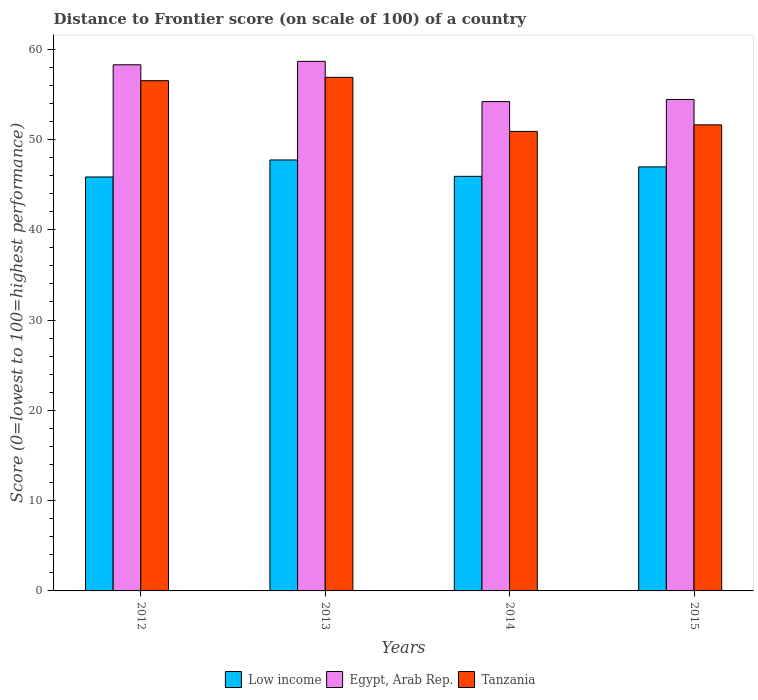How many groups of bars are there?
Provide a succinct answer. 4. Are the number of bars per tick equal to the number of legend labels?
Offer a terse response. Yes. Are the number of bars on each tick of the X-axis equal?
Keep it short and to the point. Yes. How many bars are there on the 2nd tick from the left?
Keep it short and to the point. 3. In how many cases, is the number of bars for a given year not equal to the number of legend labels?
Give a very brief answer. 0. What is the distance to frontier score of in Tanzania in 2014?
Give a very brief answer. 50.89. Across all years, what is the maximum distance to frontier score of in Low income?
Make the answer very short. 47.73. Across all years, what is the minimum distance to frontier score of in Egypt, Arab Rep.?
Provide a succinct answer. 54.19. In which year was the distance to frontier score of in Low income minimum?
Provide a short and direct response. 2012. What is the total distance to frontier score of in Low income in the graph?
Keep it short and to the point. 186.45. What is the difference between the distance to frontier score of in Low income in 2013 and that in 2015?
Your answer should be compact. 0.77. What is the difference between the distance to frontier score of in Low income in 2014 and the distance to frontier score of in Egypt, Arab Rep. in 2013?
Make the answer very short. -12.73. What is the average distance to frontier score of in Egypt, Arab Rep. per year?
Offer a terse response. 56.39. In the year 2015, what is the difference between the distance to frontier score of in Tanzania and distance to frontier score of in Low income?
Offer a very short reply. 4.66. What is the ratio of the distance to frontier score of in Low income in 2013 to that in 2014?
Give a very brief answer. 1.04. Is the distance to frontier score of in Tanzania in 2012 less than that in 2014?
Your answer should be compact. No. What is the difference between the highest and the second highest distance to frontier score of in Tanzania?
Your answer should be compact. 0.37. What is the difference between the highest and the lowest distance to frontier score of in Egypt, Arab Rep.?
Provide a short and direct response. 4.46. What does the 2nd bar from the left in 2012 represents?
Offer a very short reply. Egypt, Arab Rep. What does the 2nd bar from the right in 2012 represents?
Your answer should be compact. Egypt, Arab Rep. Is it the case that in every year, the sum of the distance to frontier score of in Tanzania and distance to frontier score of in Low income is greater than the distance to frontier score of in Egypt, Arab Rep.?
Ensure brevity in your answer.  Yes. How many bars are there?
Give a very brief answer. 12. Are all the bars in the graph horizontal?
Ensure brevity in your answer.  No. Does the graph contain grids?
Your answer should be compact. No. What is the title of the graph?
Offer a very short reply. Distance to Frontier score (on scale of 100) of a country. Does "Ghana" appear as one of the legend labels in the graph?
Your answer should be very brief. No. What is the label or title of the X-axis?
Make the answer very short. Years. What is the label or title of the Y-axis?
Your answer should be compact. Score (0=lowest to 100=highest performance). What is the Score (0=lowest to 100=highest performance) in Low income in 2012?
Provide a succinct answer. 45.84. What is the Score (0=lowest to 100=highest performance) of Egypt, Arab Rep. in 2012?
Offer a very short reply. 58.27. What is the Score (0=lowest to 100=highest performance) of Tanzania in 2012?
Your response must be concise. 56.51. What is the Score (0=lowest to 100=highest performance) in Low income in 2013?
Make the answer very short. 47.73. What is the Score (0=lowest to 100=highest performance) of Egypt, Arab Rep. in 2013?
Provide a short and direct response. 58.65. What is the Score (0=lowest to 100=highest performance) of Tanzania in 2013?
Keep it short and to the point. 56.88. What is the Score (0=lowest to 100=highest performance) in Low income in 2014?
Ensure brevity in your answer.  45.92. What is the Score (0=lowest to 100=highest performance) in Egypt, Arab Rep. in 2014?
Provide a succinct answer. 54.19. What is the Score (0=lowest to 100=highest performance) in Tanzania in 2014?
Your answer should be compact. 50.89. What is the Score (0=lowest to 100=highest performance) in Low income in 2015?
Your answer should be very brief. 46.96. What is the Score (0=lowest to 100=highest performance) of Egypt, Arab Rep. in 2015?
Offer a terse response. 54.43. What is the Score (0=lowest to 100=highest performance) of Tanzania in 2015?
Make the answer very short. 51.62. Across all years, what is the maximum Score (0=lowest to 100=highest performance) in Low income?
Your answer should be compact. 47.73. Across all years, what is the maximum Score (0=lowest to 100=highest performance) in Egypt, Arab Rep.?
Offer a terse response. 58.65. Across all years, what is the maximum Score (0=lowest to 100=highest performance) of Tanzania?
Ensure brevity in your answer.  56.88. Across all years, what is the minimum Score (0=lowest to 100=highest performance) of Low income?
Provide a short and direct response. 45.84. Across all years, what is the minimum Score (0=lowest to 100=highest performance) of Egypt, Arab Rep.?
Offer a very short reply. 54.19. Across all years, what is the minimum Score (0=lowest to 100=highest performance) of Tanzania?
Provide a short and direct response. 50.89. What is the total Score (0=lowest to 100=highest performance) of Low income in the graph?
Your answer should be very brief. 186.45. What is the total Score (0=lowest to 100=highest performance) in Egypt, Arab Rep. in the graph?
Your response must be concise. 225.54. What is the total Score (0=lowest to 100=highest performance) in Tanzania in the graph?
Offer a very short reply. 215.9. What is the difference between the Score (0=lowest to 100=highest performance) in Low income in 2012 and that in 2013?
Your answer should be compact. -1.89. What is the difference between the Score (0=lowest to 100=highest performance) in Egypt, Arab Rep. in 2012 and that in 2013?
Your response must be concise. -0.38. What is the difference between the Score (0=lowest to 100=highest performance) in Tanzania in 2012 and that in 2013?
Your answer should be very brief. -0.37. What is the difference between the Score (0=lowest to 100=highest performance) of Low income in 2012 and that in 2014?
Make the answer very short. -0.07. What is the difference between the Score (0=lowest to 100=highest performance) in Egypt, Arab Rep. in 2012 and that in 2014?
Your answer should be compact. 4.08. What is the difference between the Score (0=lowest to 100=highest performance) of Tanzania in 2012 and that in 2014?
Provide a short and direct response. 5.62. What is the difference between the Score (0=lowest to 100=highest performance) in Low income in 2012 and that in 2015?
Give a very brief answer. -1.12. What is the difference between the Score (0=lowest to 100=highest performance) in Egypt, Arab Rep. in 2012 and that in 2015?
Offer a very short reply. 3.84. What is the difference between the Score (0=lowest to 100=highest performance) in Tanzania in 2012 and that in 2015?
Your response must be concise. 4.89. What is the difference between the Score (0=lowest to 100=highest performance) of Low income in 2013 and that in 2014?
Your answer should be compact. 1.81. What is the difference between the Score (0=lowest to 100=highest performance) in Egypt, Arab Rep. in 2013 and that in 2014?
Provide a short and direct response. 4.46. What is the difference between the Score (0=lowest to 100=highest performance) of Tanzania in 2013 and that in 2014?
Ensure brevity in your answer.  5.99. What is the difference between the Score (0=lowest to 100=highest performance) of Low income in 2013 and that in 2015?
Offer a very short reply. 0.77. What is the difference between the Score (0=lowest to 100=highest performance) of Egypt, Arab Rep. in 2013 and that in 2015?
Your response must be concise. 4.22. What is the difference between the Score (0=lowest to 100=highest performance) in Tanzania in 2013 and that in 2015?
Provide a short and direct response. 5.26. What is the difference between the Score (0=lowest to 100=highest performance) of Low income in 2014 and that in 2015?
Make the answer very short. -1.05. What is the difference between the Score (0=lowest to 100=highest performance) of Egypt, Arab Rep. in 2014 and that in 2015?
Make the answer very short. -0.24. What is the difference between the Score (0=lowest to 100=highest performance) in Tanzania in 2014 and that in 2015?
Offer a very short reply. -0.73. What is the difference between the Score (0=lowest to 100=highest performance) in Low income in 2012 and the Score (0=lowest to 100=highest performance) in Egypt, Arab Rep. in 2013?
Keep it short and to the point. -12.81. What is the difference between the Score (0=lowest to 100=highest performance) in Low income in 2012 and the Score (0=lowest to 100=highest performance) in Tanzania in 2013?
Give a very brief answer. -11.04. What is the difference between the Score (0=lowest to 100=highest performance) of Egypt, Arab Rep. in 2012 and the Score (0=lowest to 100=highest performance) of Tanzania in 2013?
Provide a succinct answer. 1.39. What is the difference between the Score (0=lowest to 100=highest performance) of Low income in 2012 and the Score (0=lowest to 100=highest performance) of Egypt, Arab Rep. in 2014?
Your answer should be compact. -8.35. What is the difference between the Score (0=lowest to 100=highest performance) of Low income in 2012 and the Score (0=lowest to 100=highest performance) of Tanzania in 2014?
Ensure brevity in your answer.  -5.05. What is the difference between the Score (0=lowest to 100=highest performance) of Egypt, Arab Rep. in 2012 and the Score (0=lowest to 100=highest performance) of Tanzania in 2014?
Make the answer very short. 7.38. What is the difference between the Score (0=lowest to 100=highest performance) in Low income in 2012 and the Score (0=lowest to 100=highest performance) in Egypt, Arab Rep. in 2015?
Make the answer very short. -8.59. What is the difference between the Score (0=lowest to 100=highest performance) of Low income in 2012 and the Score (0=lowest to 100=highest performance) of Tanzania in 2015?
Your response must be concise. -5.78. What is the difference between the Score (0=lowest to 100=highest performance) in Egypt, Arab Rep. in 2012 and the Score (0=lowest to 100=highest performance) in Tanzania in 2015?
Make the answer very short. 6.65. What is the difference between the Score (0=lowest to 100=highest performance) of Low income in 2013 and the Score (0=lowest to 100=highest performance) of Egypt, Arab Rep. in 2014?
Your answer should be very brief. -6.46. What is the difference between the Score (0=lowest to 100=highest performance) of Low income in 2013 and the Score (0=lowest to 100=highest performance) of Tanzania in 2014?
Make the answer very short. -3.16. What is the difference between the Score (0=lowest to 100=highest performance) of Egypt, Arab Rep. in 2013 and the Score (0=lowest to 100=highest performance) of Tanzania in 2014?
Your response must be concise. 7.76. What is the difference between the Score (0=lowest to 100=highest performance) in Low income in 2013 and the Score (0=lowest to 100=highest performance) in Egypt, Arab Rep. in 2015?
Ensure brevity in your answer.  -6.7. What is the difference between the Score (0=lowest to 100=highest performance) of Low income in 2013 and the Score (0=lowest to 100=highest performance) of Tanzania in 2015?
Offer a terse response. -3.89. What is the difference between the Score (0=lowest to 100=highest performance) in Egypt, Arab Rep. in 2013 and the Score (0=lowest to 100=highest performance) in Tanzania in 2015?
Keep it short and to the point. 7.03. What is the difference between the Score (0=lowest to 100=highest performance) of Low income in 2014 and the Score (0=lowest to 100=highest performance) of Egypt, Arab Rep. in 2015?
Your answer should be compact. -8.51. What is the difference between the Score (0=lowest to 100=highest performance) of Low income in 2014 and the Score (0=lowest to 100=highest performance) of Tanzania in 2015?
Offer a terse response. -5.7. What is the difference between the Score (0=lowest to 100=highest performance) in Egypt, Arab Rep. in 2014 and the Score (0=lowest to 100=highest performance) in Tanzania in 2015?
Make the answer very short. 2.57. What is the average Score (0=lowest to 100=highest performance) in Low income per year?
Make the answer very short. 46.61. What is the average Score (0=lowest to 100=highest performance) in Egypt, Arab Rep. per year?
Make the answer very short. 56.38. What is the average Score (0=lowest to 100=highest performance) in Tanzania per year?
Make the answer very short. 53.98. In the year 2012, what is the difference between the Score (0=lowest to 100=highest performance) in Low income and Score (0=lowest to 100=highest performance) in Egypt, Arab Rep.?
Your answer should be very brief. -12.43. In the year 2012, what is the difference between the Score (0=lowest to 100=highest performance) of Low income and Score (0=lowest to 100=highest performance) of Tanzania?
Your response must be concise. -10.67. In the year 2012, what is the difference between the Score (0=lowest to 100=highest performance) of Egypt, Arab Rep. and Score (0=lowest to 100=highest performance) of Tanzania?
Your answer should be compact. 1.76. In the year 2013, what is the difference between the Score (0=lowest to 100=highest performance) in Low income and Score (0=lowest to 100=highest performance) in Egypt, Arab Rep.?
Make the answer very short. -10.92. In the year 2013, what is the difference between the Score (0=lowest to 100=highest performance) of Low income and Score (0=lowest to 100=highest performance) of Tanzania?
Your response must be concise. -9.15. In the year 2013, what is the difference between the Score (0=lowest to 100=highest performance) of Egypt, Arab Rep. and Score (0=lowest to 100=highest performance) of Tanzania?
Ensure brevity in your answer.  1.77. In the year 2014, what is the difference between the Score (0=lowest to 100=highest performance) of Low income and Score (0=lowest to 100=highest performance) of Egypt, Arab Rep.?
Make the answer very short. -8.27. In the year 2014, what is the difference between the Score (0=lowest to 100=highest performance) in Low income and Score (0=lowest to 100=highest performance) in Tanzania?
Offer a terse response. -4.97. In the year 2014, what is the difference between the Score (0=lowest to 100=highest performance) of Egypt, Arab Rep. and Score (0=lowest to 100=highest performance) of Tanzania?
Offer a very short reply. 3.3. In the year 2015, what is the difference between the Score (0=lowest to 100=highest performance) of Low income and Score (0=lowest to 100=highest performance) of Egypt, Arab Rep.?
Ensure brevity in your answer.  -7.47. In the year 2015, what is the difference between the Score (0=lowest to 100=highest performance) of Low income and Score (0=lowest to 100=highest performance) of Tanzania?
Offer a terse response. -4.66. In the year 2015, what is the difference between the Score (0=lowest to 100=highest performance) of Egypt, Arab Rep. and Score (0=lowest to 100=highest performance) of Tanzania?
Your response must be concise. 2.81. What is the ratio of the Score (0=lowest to 100=highest performance) in Low income in 2012 to that in 2013?
Keep it short and to the point. 0.96. What is the ratio of the Score (0=lowest to 100=highest performance) of Egypt, Arab Rep. in 2012 to that in 2013?
Make the answer very short. 0.99. What is the ratio of the Score (0=lowest to 100=highest performance) of Tanzania in 2012 to that in 2013?
Ensure brevity in your answer.  0.99. What is the ratio of the Score (0=lowest to 100=highest performance) of Egypt, Arab Rep. in 2012 to that in 2014?
Ensure brevity in your answer.  1.08. What is the ratio of the Score (0=lowest to 100=highest performance) in Tanzania in 2012 to that in 2014?
Provide a succinct answer. 1.11. What is the ratio of the Score (0=lowest to 100=highest performance) of Low income in 2012 to that in 2015?
Your response must be concise. 0.98. What is the ratio of the Score (0=lowest to 100=highest performance) in Egypt, Arab Rep. in 2012 to that in 2015?
Ensure brevity in your answer.  1.07. What is the ratio of the Score (0=lowest to 100=highest performance) of Tanzania in 2012 to that in 2015?
Your response must be concise. 1.09. What is the ratio of the Score (0=lowest to 100=highest performance) of Low income in 2013 to that in 2014?
Your answer should be very brief. 1.04. What is the ratio of the Score (0=lowest to 100=highest performance) in Egypt, Arab Rep. in 2013 to that in 2014?
Give a very brief answer. 1.08. What is the ratio of the Score (0=lowest to 100=highest performance) of Tanzania in 2013 to that in 2014?
Your answer should be very brief. 1.12. What is the ratio of the Score (0=lowest to 100=highest performance) of Low income in 2013 to that in 2015?
Your answer should be compact. 1.02. What is the ratio of the Score (0=lowest to 100=highest performance) in Egypt, Arab Rep. in 2013 to that in 2015?
Ensure brevity in your answer.  1.08. What is the ratio of the Score (0=lowest to 100=highest performance) in Tanzania in 2013 to that in 2015?
Provide a short and direct response. 1.1. What is the ratio of the Score (0=lowest to 100=highest performance) of Low income in 2014 to that in 2015?
Make the answer very short. 0.98. What is the ratio of the Score (0=lowest to 100=highest performance) of Egypt, Arab Rep. in 2014 to that in 2015?
Your answer should be compact. 1. What is the ratio of the Score (0=lowest to 100=highest performance) in Tanzania in 2014 to that in 2015?
Your answer should be very brief. 0.99. What is the difference between the highest and the second highest Score (0=lowest to 100=highest performance) in Low income?
Provide a short and direct response. 0.77. What is the difference between the highest and the second highest Score (0=lowest to 100=highest performance) of Egypt, Arab Rep.?
Keep it short and to the point. 0.38. What is the difference between the highest and the second highest Score (0=lowest to 100=highest performance) in Tanzania?
Make the answer very short. 0.37. What is the difference between the highest and the lowest Score (0=lowest to 100=highest performance) of Low income?
Keep it short and to the point. 1.89. What is the difference between the highest and the lowest Score (0=lowest to 100=highest performance) in Egypt, Arab Rep.?
Your answer should be compact. 4.46. What is the difference between the highest and the lowest Score (0=lowest to 100=highest performance) in Tanzania?
Ensure brevity in your answer.  5.99. 